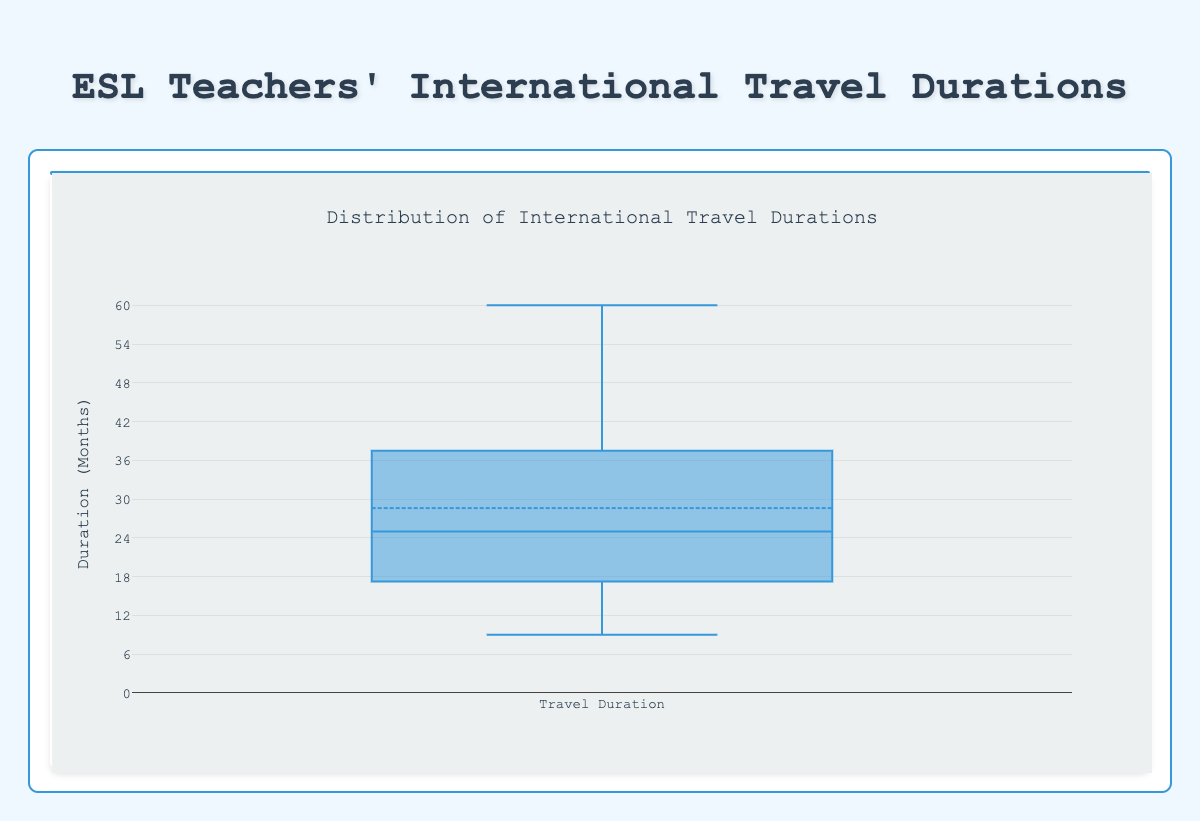what is the median duration of international travel for these teachers? In a box plot, the median is represented by the line inside the box. Visually locate this line. Refer to the y-axis value corresponding to this line.
Answer: 25 Which teacher has the longest international travel experience? Examine the individual data points in the plot. Look for the highest point, which indicates the longest travel duration.
Answer: Mia Rodriguez What is the range of the travel durations? The range is the difference between the maximum and minimum values in the plot. Identify the highest and lowest data points and subtract the minimum from the maximum.
Answer: 51 How many teachers traveled internationally for more than 30 months? Count the number of data points above the y-axis value of 30 months.
Answer: 5 What is the interquartile range (IQR) of the travel durations? The IQR is the difference between the 75th and 25th percentiles, represented by the top and bottom of the box. Identify these values on the y-axis and subtract the lower quartile from the upper quartile.
Answer: 24 What is the mean travel duration for these teachers? The mean is the average of the data points. Sum all the durations and divide by the number of teachers. For this data: (24 + 36 + 12 + 48 + 20 + 30 + 18 + 60 + 25 + 15 + 42 + 9 + 33) / 13 = 28.38
Answer: 28.38 Which teacher has the shortest duration of international travel? Look for the lowest data point on the plot, indicating the shortest travel duration.
Answer: Olivia Wilson Are there any outliers in the travel durations? In a box plot, outliers are usually represented by points outside the whiskers. Scan the plot for any such points.
Answer: No What is the difference between the median and the first quartile values? Identify the median and the first quartile (bottom of the box). Subtract the first quartile value from the median value.
Answer: 12 Which quartile includes the value 42 months of travel? Identify the segments of the box plot and locate the value 42 within one of these sections. The upper quartile encompasses values between 37 and 50 (approx).
Answer: Upper quartile 